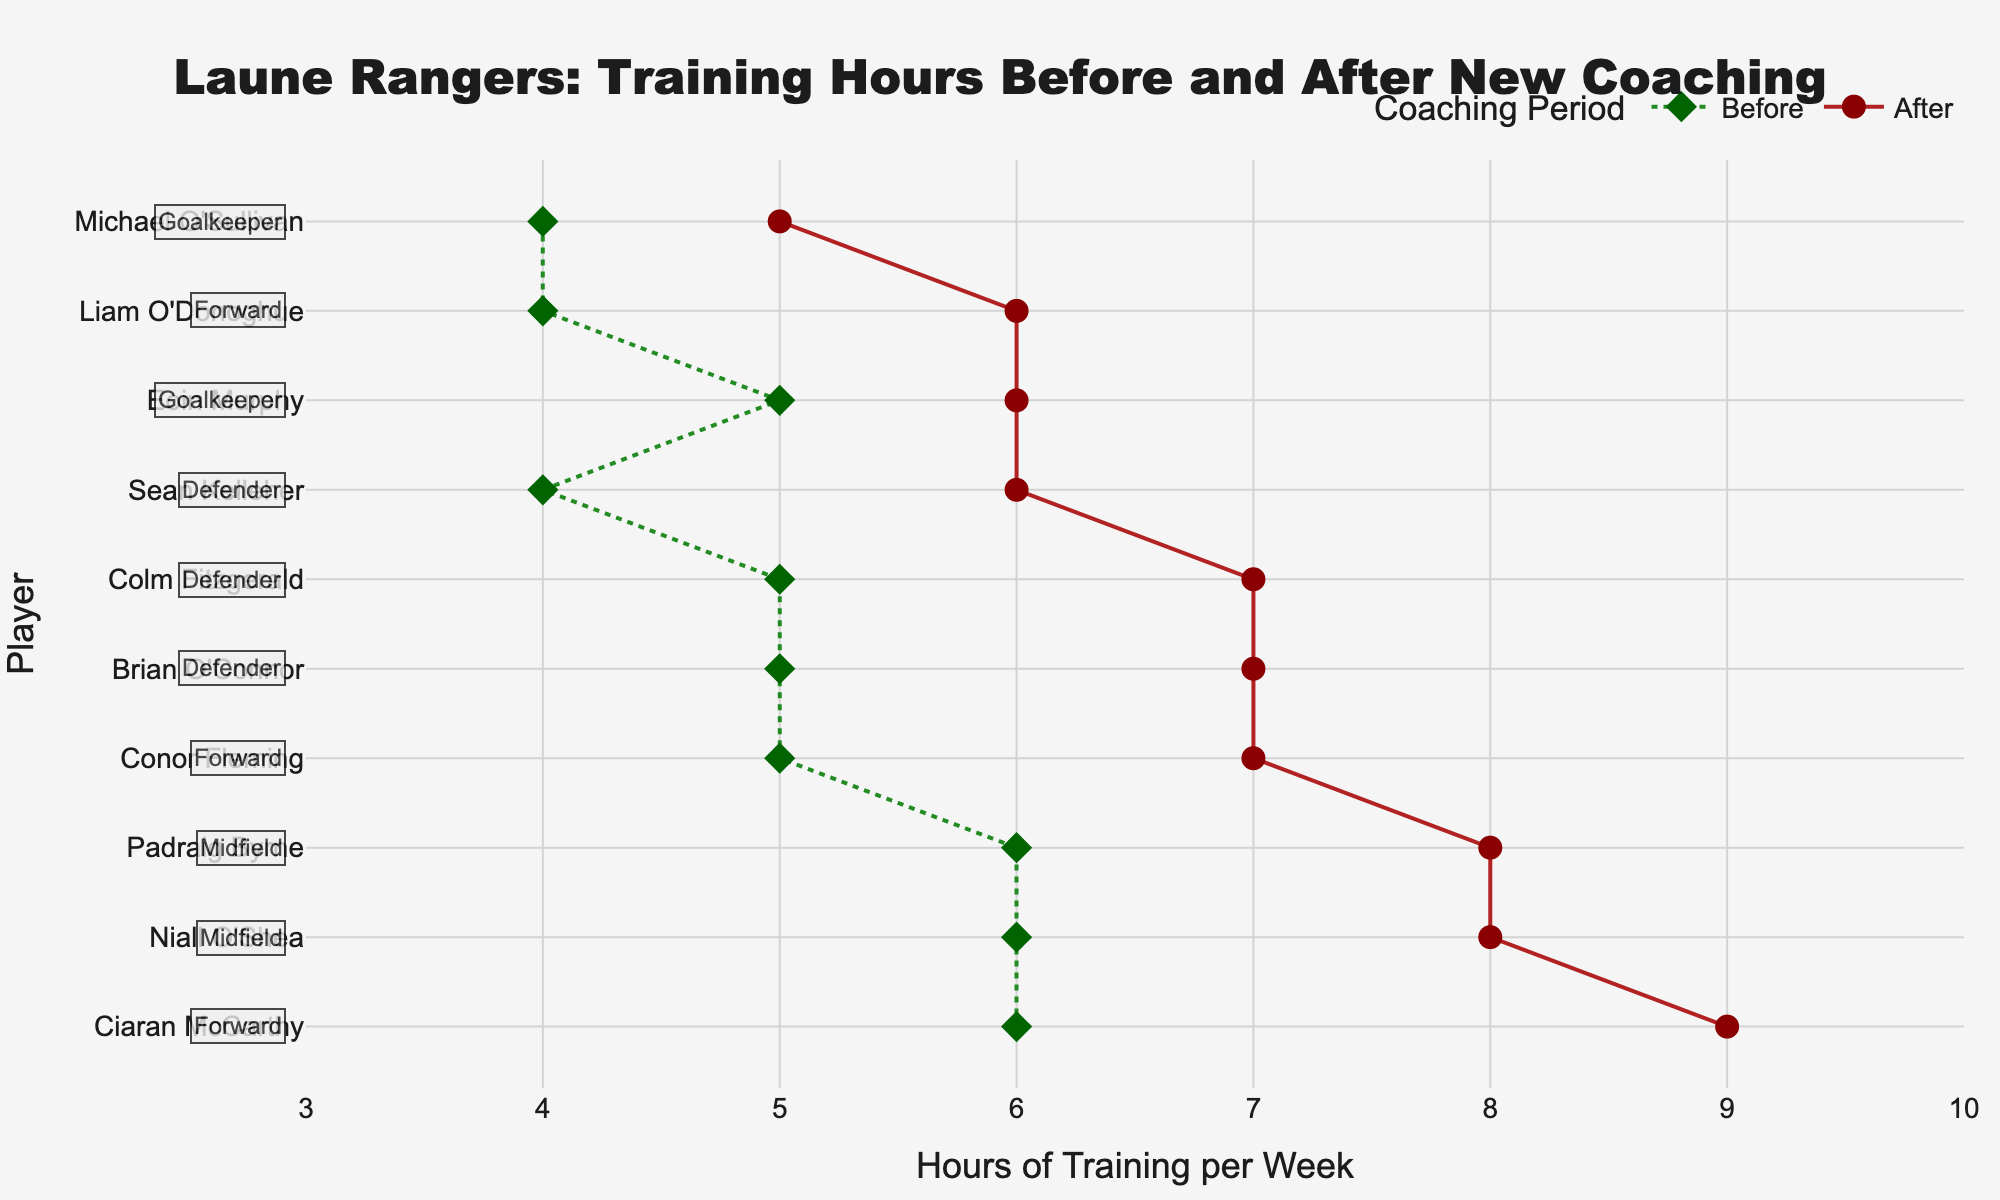What is the title of the figure? The title is located at the top of the chart and it provides the subject of the graph. It reads "Laune Rangers: Training Hours Before and After New Coaching".
Answer: Laune Rangers: Training Hours Before and After New Coaching How many total players are represented in the figure? Count the number of unique names listed along the y-axis. Each name corresponds to a player.
Answer: 10 Which player shows the largest increase in training hours? Compare the difference in 'Hours before' and 'Hours after' for each player. Ciaran McCarthy has the largest increase, from 6 hours to 9 hours, a change of 3 hours.
Answer: Ciaran McCarthy What position does Niall O'Shea play? Check the annotation next to Niall O'Shea's name on the y-axis. The annotation indicates his position.
Answer: Midfield What are the training hours for Brian O'Connor after the new coaching techniques were introduced? Locate Brian O'Connor's name on the y-axis and move across to the 'After' column. His training hours increased to 7.
Answer: 7 Which player trained the least after the new coaching techniques were introduced? Find the player with the smallest value in the 'Hours after' column. Michael O'Sullivan trained for 5 hours.
Answer: Michael O'Sullivan On average, how many hours did the players train before the new coaching techniques were introduced? Sum the 'Hours before' for all players and divide by the number of players: (6+5+4+5+6+5+6+4+5+4)/10 = 50/10 = 5 hours.
Answer: 5 Which two players are goalkeepers, and how did their training hours change? Identify the goalkeepers from the annotations: Eoin Murphy and Michael O'Sullivan. Eoin Murphy increased from 5 to 6 hours; Michael O'Sullivan from 4 to 5 hours.
Answer: Eoin Murphy trained 1 hour more, Michael O'Sullivan trained 1 hour more How many players trained 7 hours or more after the new coaching techniques? Check the number of players with 'Hours after' values 7 or more. There are 6 players: Niall O'Shea, Conor Fleming, Sean Kelleher, Ciaran McCarthy, Brian O'Connor, and Colm Fitzgerald.
Answer: 6 Which position has the highest average increase in training hours? Calculate the average increase for each position: 
- Midfield (Niall O'Shea, Padraig Byrne): avg = (8-6 + 8-6)/2 = 2 
- Forward (Conor Fleming, Ciaran McCarthy, Liam O'Donoghue): avg = (7-5 + 9-6 + 6-4)/3 = 2 
- Defender (Sean Kelleher, Brian O'Connor, Colm Fitzgerald): avg = (6-4 + 7-5 + 7-5)/3 = 2 
- Goalkeeper (Eoin Murphy, Michael O'Sullivan): avg = (6-5 + 5-4)/2 = 1. 
Midfield, Forward, and Defender all have the highest average increase of 2.
Answer: Midfield, Forward, Defender 